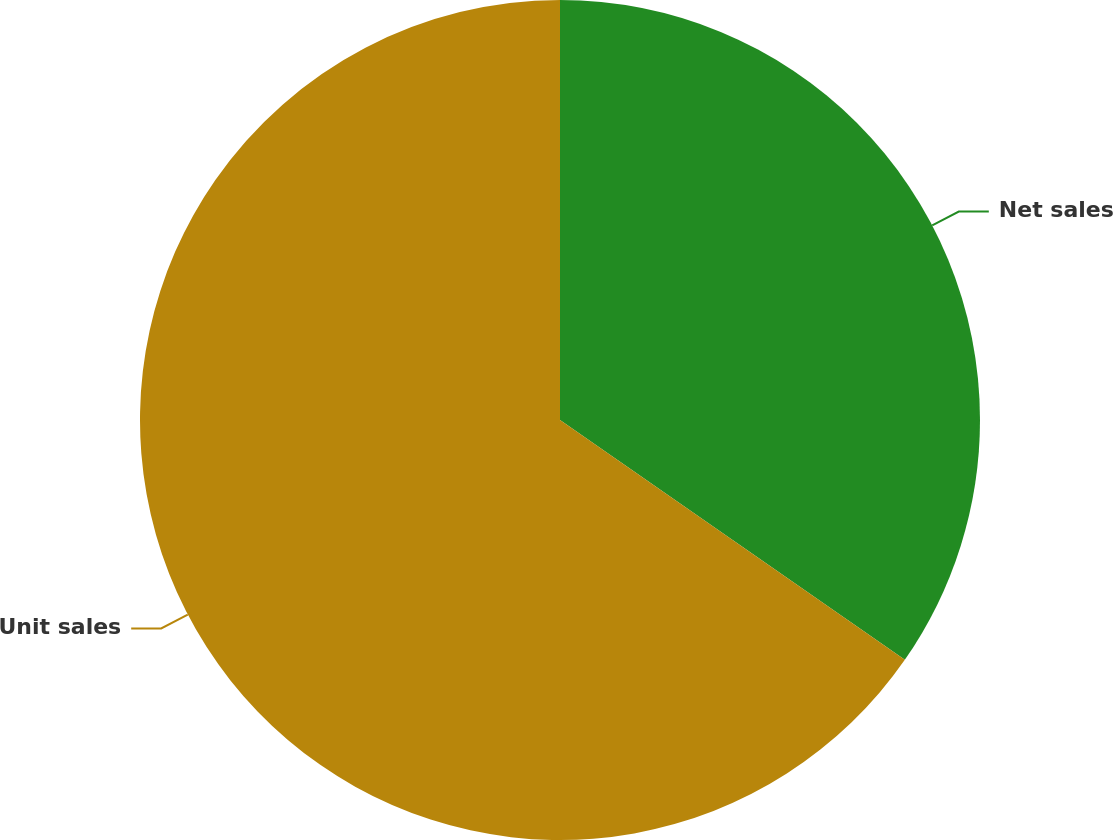<chart> <loc_0><loc_0><loc_500><loc_500><pie_chart><fcel>Net sales<fcel>Unit sales<nl><fcel>34.67%<fcel>65.33%<nl></chart> 